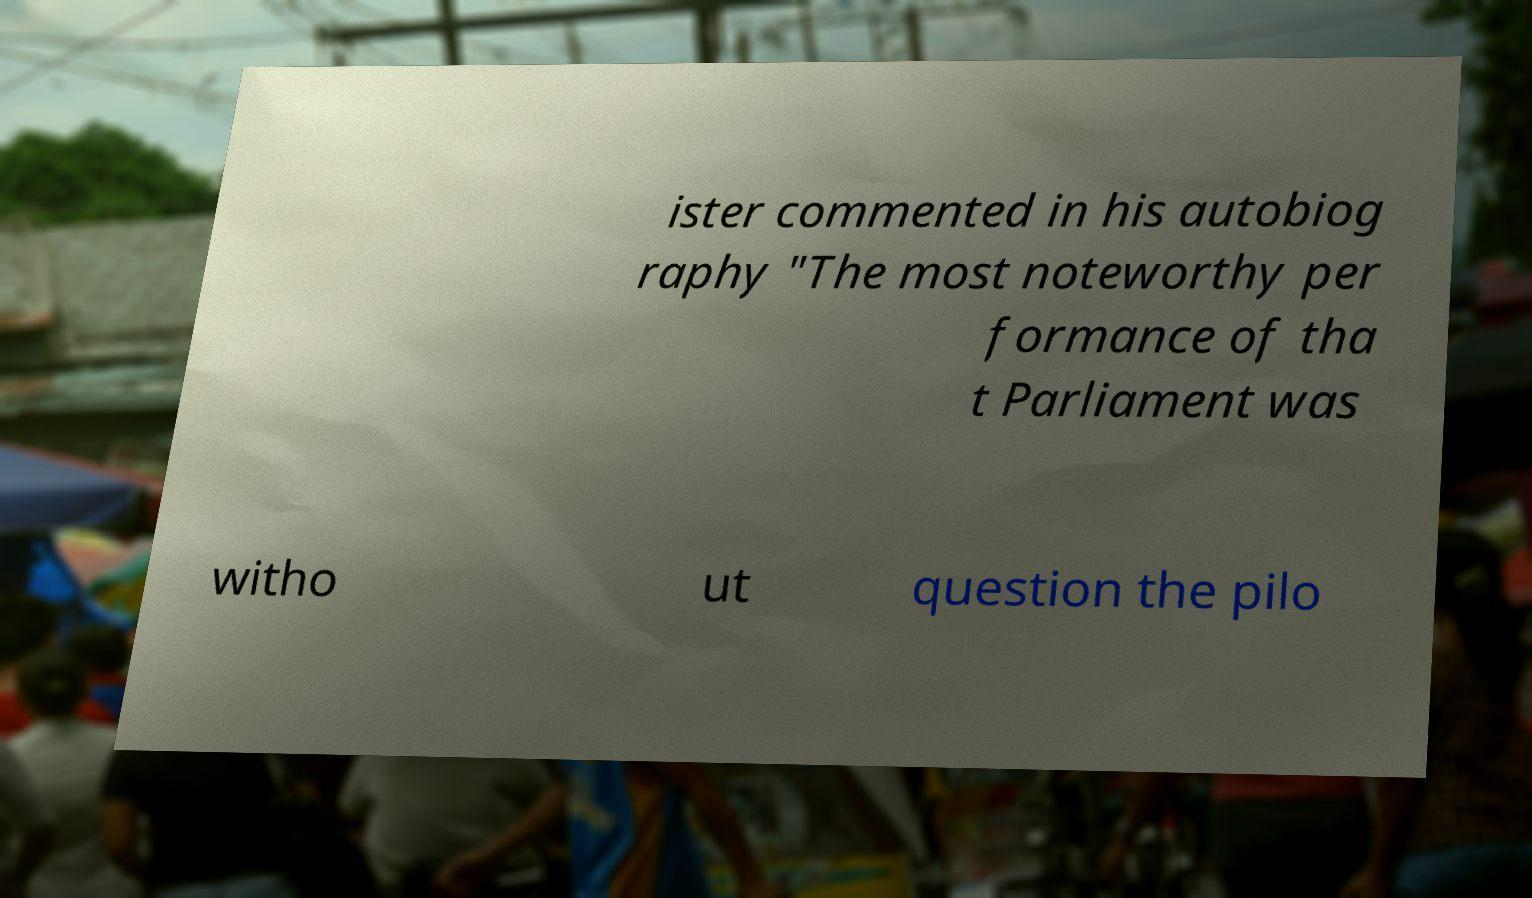Can you read and provide the text displayed in the image?This photo seems to have some interesting text. Can you extract and type it out for me? ister commented in his autobiog raphy "The most noteworthy per formance of tha t Parliament was witho ut question the pilo 